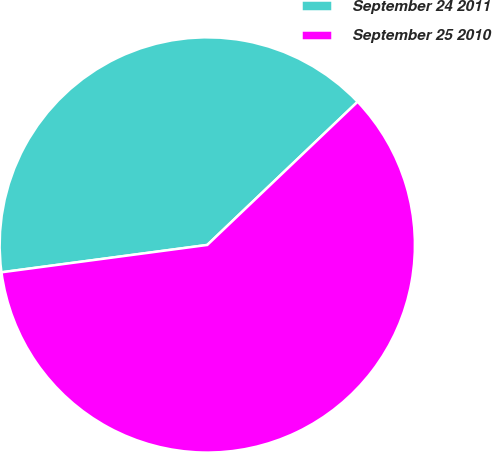Convert chart. <chart><loc_0><loc_0><loc_500><loc_500><pie_chart><fcel>September 24 2011<fcel>September 25 2010<nl><fcel>39.99%<fcel>60.01%<nl></chart> 